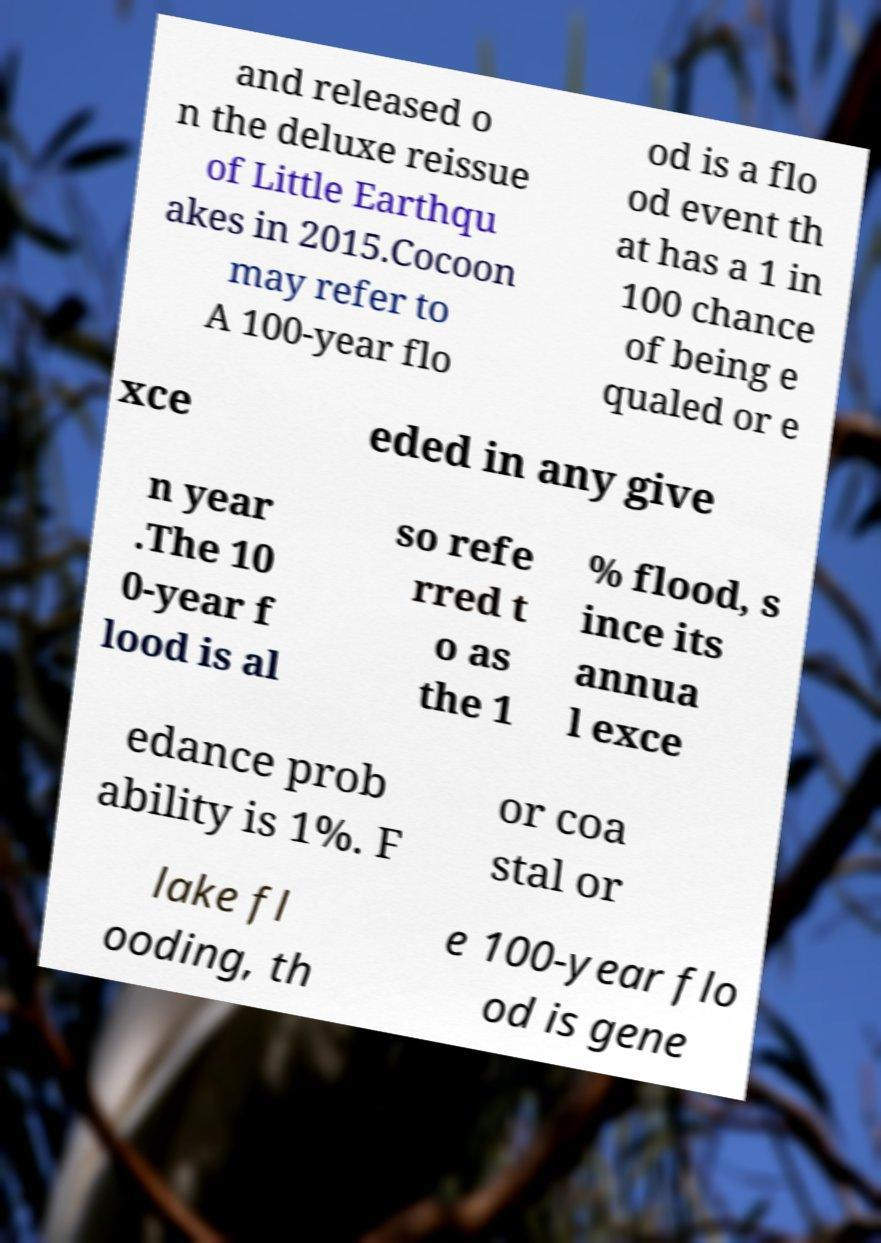Can you read and provide the text displayed in the image?This photo seems to have some interesting text. Can you extract and type it out for me? and released o n the deluxe reissue of Little Earthqu akes in 2015.Cocoon may refer to A 100-year flo od is a flo od event th at has a 1 in 100 chance of being e qualed or e xce eded in any give n year .The 10 0-year f lood is al so refe rred t o as the 1 % flood, s ince its annua l exce edance prob ability is 1%. F or coa stal or lake fl ooding, th e 100-year flo od is gene 